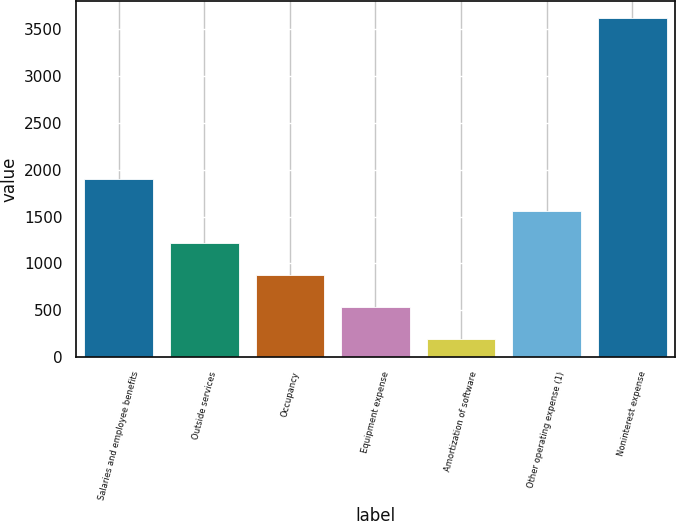Convert chart to OTSL. <chart><loc_0><loc_0><loc_500><loc_500><bar_chart><fcel>Salaries and employee benefits<fcel>Outside services<fcel>Occupancy<fcel>Equipment expense<fcel>Amortization of software<fcel>Other operating expense (1)<fcel>Noninterest expense<nl><fcel>1904<fcel>1218<fcel>875<fcel>532<fcel>189<fcel>1561<fcel>3619<nl></chart> 